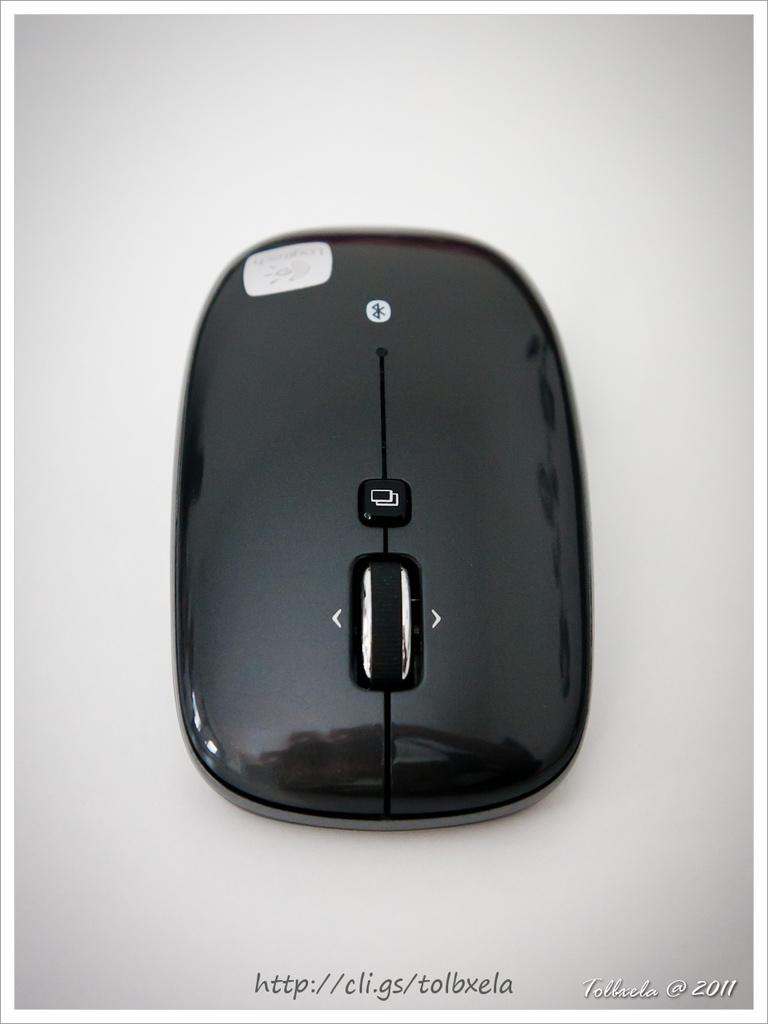Provide a one-sentence caption for the provided image. A cordless bluetooth mouse made by the company Logitech. 